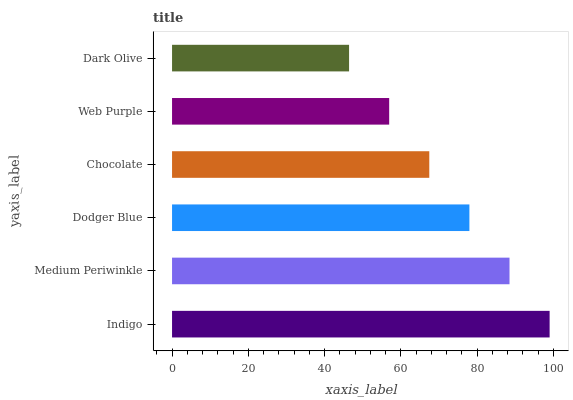Is Dark Olive the minimum?
Answer yes or no. Yes. Is Indigo the maximum?
Answer yes or no. Yes. Is Medium Periwinkle the minimum?
Answer yes or no. No. Is Medium Periwinkle the maximum?
Answer yes or no. No. Is Indigo greater than Medium Periwinkle?
Answer yes or no. Yes. Is Medium Periwinkle less than Indigo?
Answer yes or no. Yes. Is Medium Periwinkle greater than Indigo?
Answer yes or no. No. Is Indigo less than Medium Periwinkle?
Answer yes or no. No. Is Dodger Blue the high median?
Answer yes or no. Yes. Is Chocolate the low median?
Answer yes or no. Yes. Is Medium Periwinkle the high median?
Answer yes or no. No. Is Web Purple the low median?
Answer yes or no. No. 